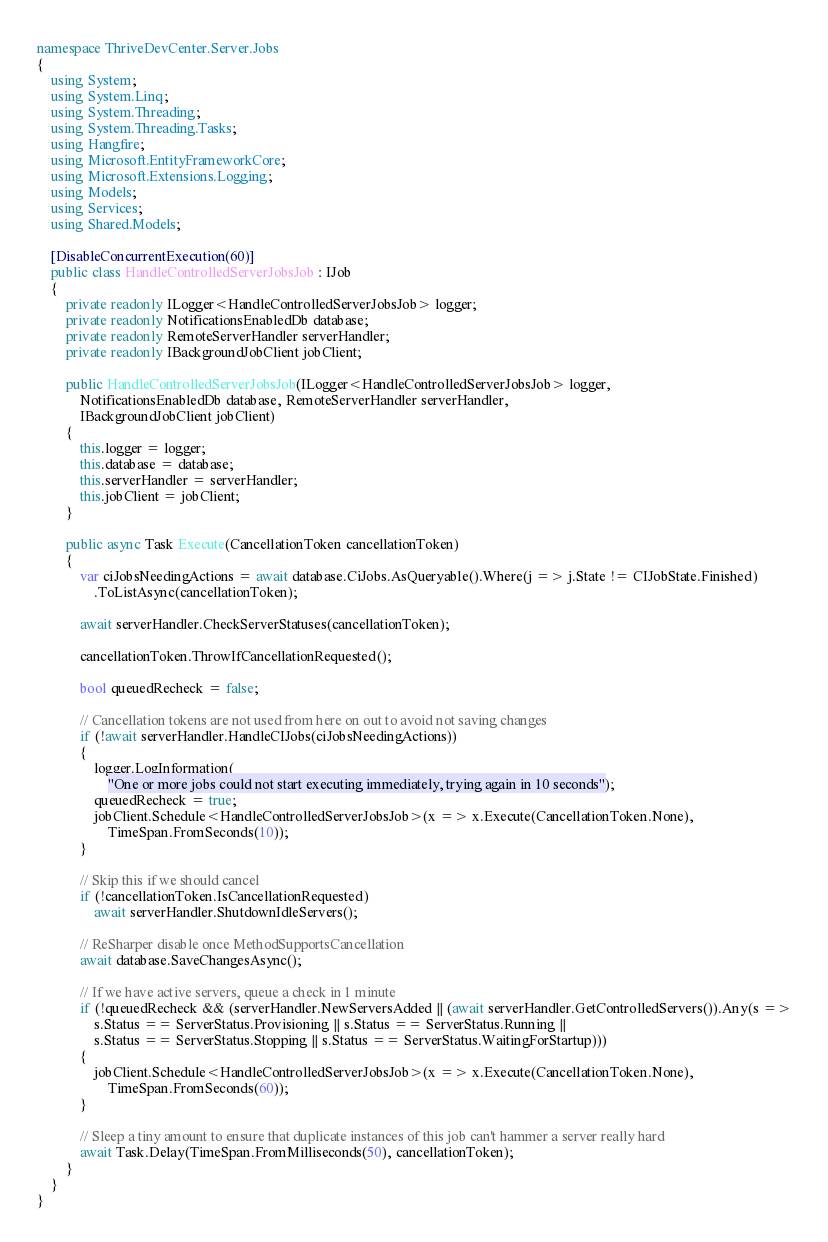<code> <loc_0><loc_0><loc_500><loc_500><_C#_>namespace ThriveDevCenter.Server.Jobs
{
    using System;
    using System.Linq;
    using System.Threading;
    using System.Threading.Tasks;
    using Hangfire;
    using Microsoft.EntityFrameworkCore;
    using Microsoft.Extensions.Logging;
    using Models;
    using Services;
    using Shared.Models;

    [DisableConcurrentExecution(60)]
    public class HandleControlledServerJobsJob : IJob
    {
        private readonly ILogger<HandleControlledServerJobsJob> logger;
        private readonly NotificationsEnabledDb database;
        private readonly RemoteServerHandler serverHandler;
        private readonly IBackgroundJobClient jobClient;

        public HandleControlledServerJobsJob(ILogger<HandleControlledServerJobsJob> logger,
            NotificationsEnabledDb database, RemoteServerHandler serverHandler,
            IBackgroundJobClient jobClient)
        {
            this.logger = logger;
            this.database = database;
            this.serverHandler = serverHandler;
            this.jobClient = jobClient;
        }

        public async Task Execute(CancellationToken cancellationToken)
        {
            var ciJobsNeedingActions = await database.CiJobs.AsQueryable().Where(j => j.State != CIJobState.Finished)
                .ToListAsync(cancellationToken);

            await serverHandler.CheckServerStatuses(cancellationToken);

            cancellationToken.ThrowIfCancellationRequested();

            bool queuedRecheck = false;

            // Cancellation tokens are not used from here on out to avoid not saving changes
            if (!await serverHandler.HandleCIJobs(ciJobsNeedingActions))
            {
                logger.LogInformation(
                    "One or more jobs could not start executing immediately, trying again in 10 seconds");
                queuedRecheck = true;
                jobClient.Schedule<HandleControlledServerJobsJob>(x => x.Execute(CancellationToken.None),
                    TimeSpan.FromSeconds(10));
            }

            // Skip this if we should cancel
            if (!cancellationToken.IsCancellationRequested)
                await serverHandler.ShutdownIdleServers();

            // ReSharper disable once MethodSupportsCancellation
            await database.SaveChangesAsync();

            // If we have active servers, queue a check in 1 minute
            if (!queuedRecheck && (serverHandler.NewServersAdded || (await serverHandler.GetControlledServers()).Any(s =>
                s.Status == ServerStatus.Provisioning || s.Status == ServerStatus.Running ||
                s.Status == ServerStatus.Stopping || s.Status == ServerStatus.WaitingForStartup)))
            {
                jobClient.Schedule<HandleControlledServerJobsJob>(x => x.Execute(CancellationToken.None),
                    TimeSpan.FromSeconds(60));
            }

            // Sleep a tiny amount to ensure that duplicate instances of this job can't hammer a server really hard
            await Task.Delay(TimeSpan.FromMilliseconds(50), cancellationToken);
        }
    }
}
</code> 